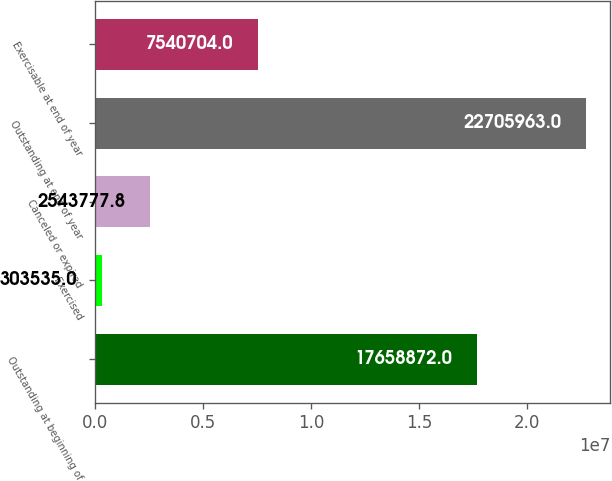<chart> <loc_0><loc_0><loc_500><loc_500><bar_chart><fcel>Outstanding at beginning of<fcel>Exercised<fcel>Canceled or expired<fcel>Outstanding at end of year<fcel>Exercisable at end of year<nl><fcel>1.76589e+07<fcel>303535<fcel>2.54378e+06<fcel>2.2706e+07<fcel>7.5407e+06<nl></chart> 